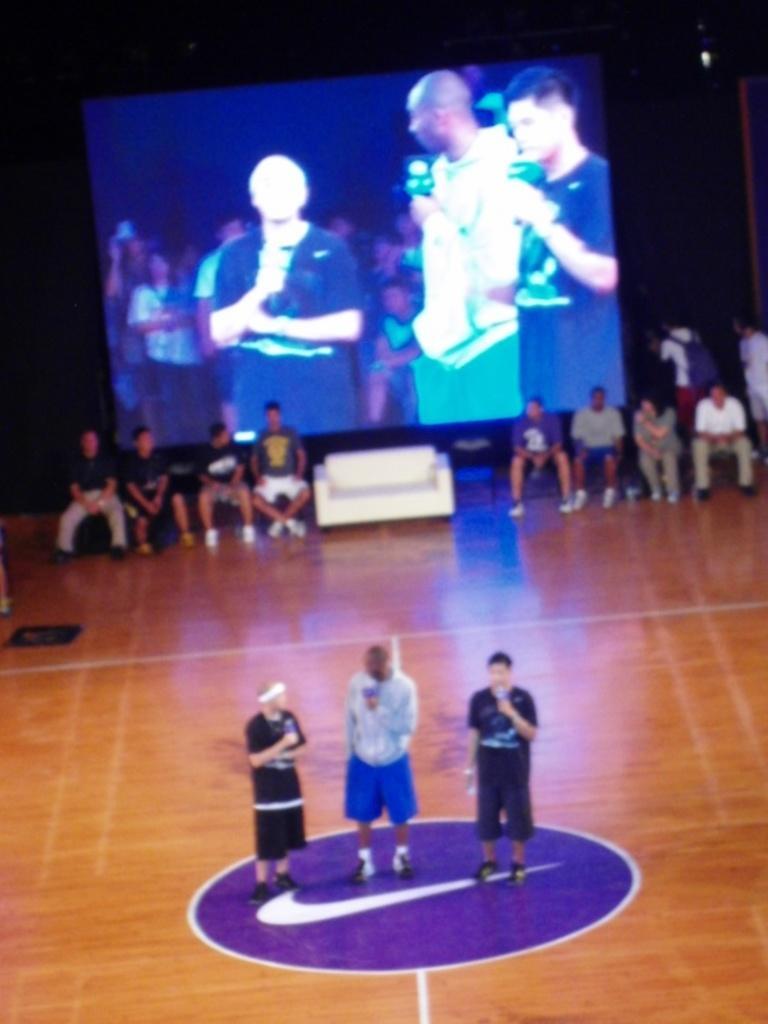Can you describe this image briefly? On the bottom there is a man who is wearing hoodie, blue short and shoe. He is holding the mic. Besides him we can see the man who is wearing black dress. On the back we can see group of persons sitting on the chair near to the couch. On the background we can see a projector screen, where we can see audience and three persons. 